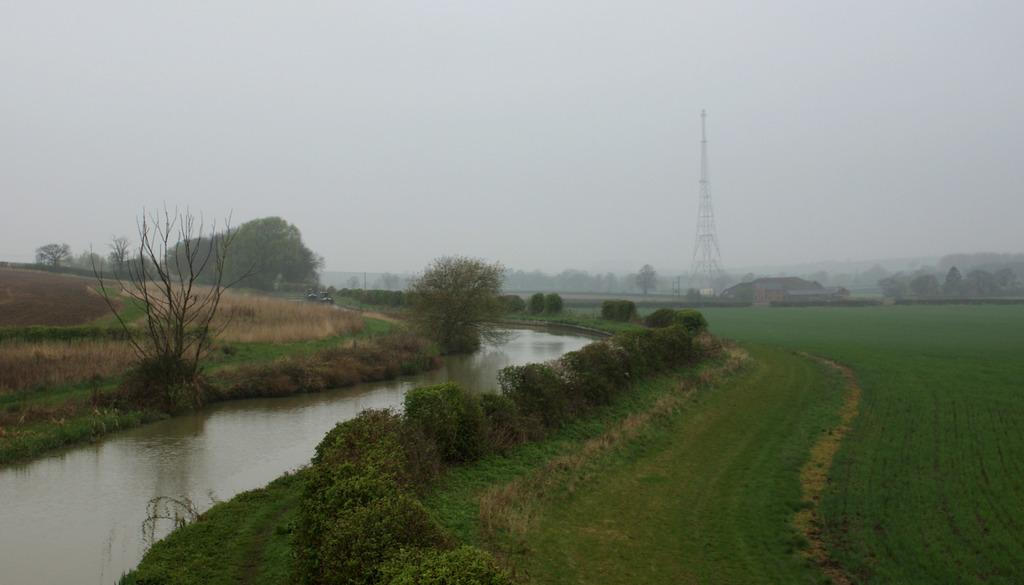What type of landscape is depicted in the image? There is a field in the image, along with a lake beside it. What can be seen on the left side of the image? There is a grassland on the left side of the image. What is visible in the background of the image? There are trees, a tower, and the sky visible in the background of the image. What type of government is in power in the image? There is no indication of a government or political system in the image; it depicts a natural landscape. 